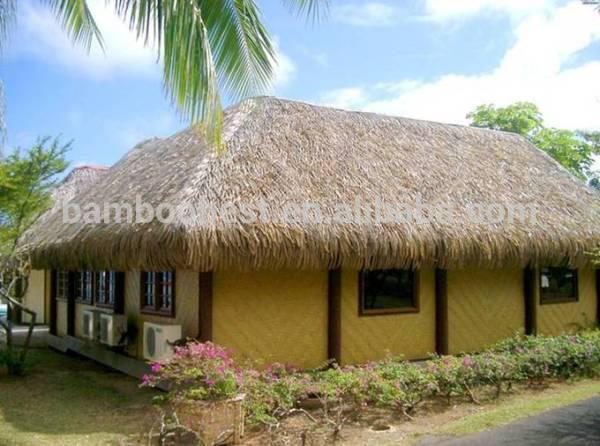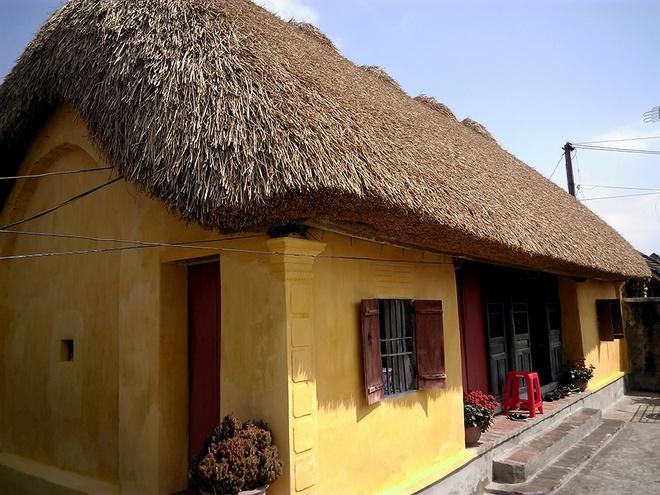The first image is the image on the left, the second image is the image on the right. For the images shown, is this caption "Each image shows one building with a thick textured roof and some flowers around it, and at least one of the roofs pictured curves around parts of the building." true? Answer yes or no. Yes. The first image is the image on the left, the second image is the image on the right. Evaluate the accuracy of this statement regarding the images: "At least one of the buildings has shutters around the windows.". Is it true? Answer yes or no. Yes. 